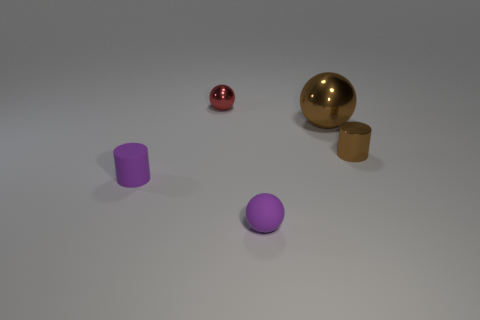Subtract all metallic spheres. How many spheres are left? 1 Add 4 cyan cylinders. How many objects exist? 9 Subtract all purple cylinders. How many cylinders are left? 1 Subtract 1 balls. How many balls are left? 2 Add 3 big brown balls. How many big brown balls exist? 4 Subtract 1 brown balls. How many objects are left? 4 Subtract all balls. How many objects are left? 2 Subtract all red cylinders. Subtract all brown cubes. How many cylinders are left? 2 Subtract all brown cylinders. How many gray spheres are left? 0 Subtract all metallic cylinders. Subtract all small purple matte objects. How many objects are left? 2 